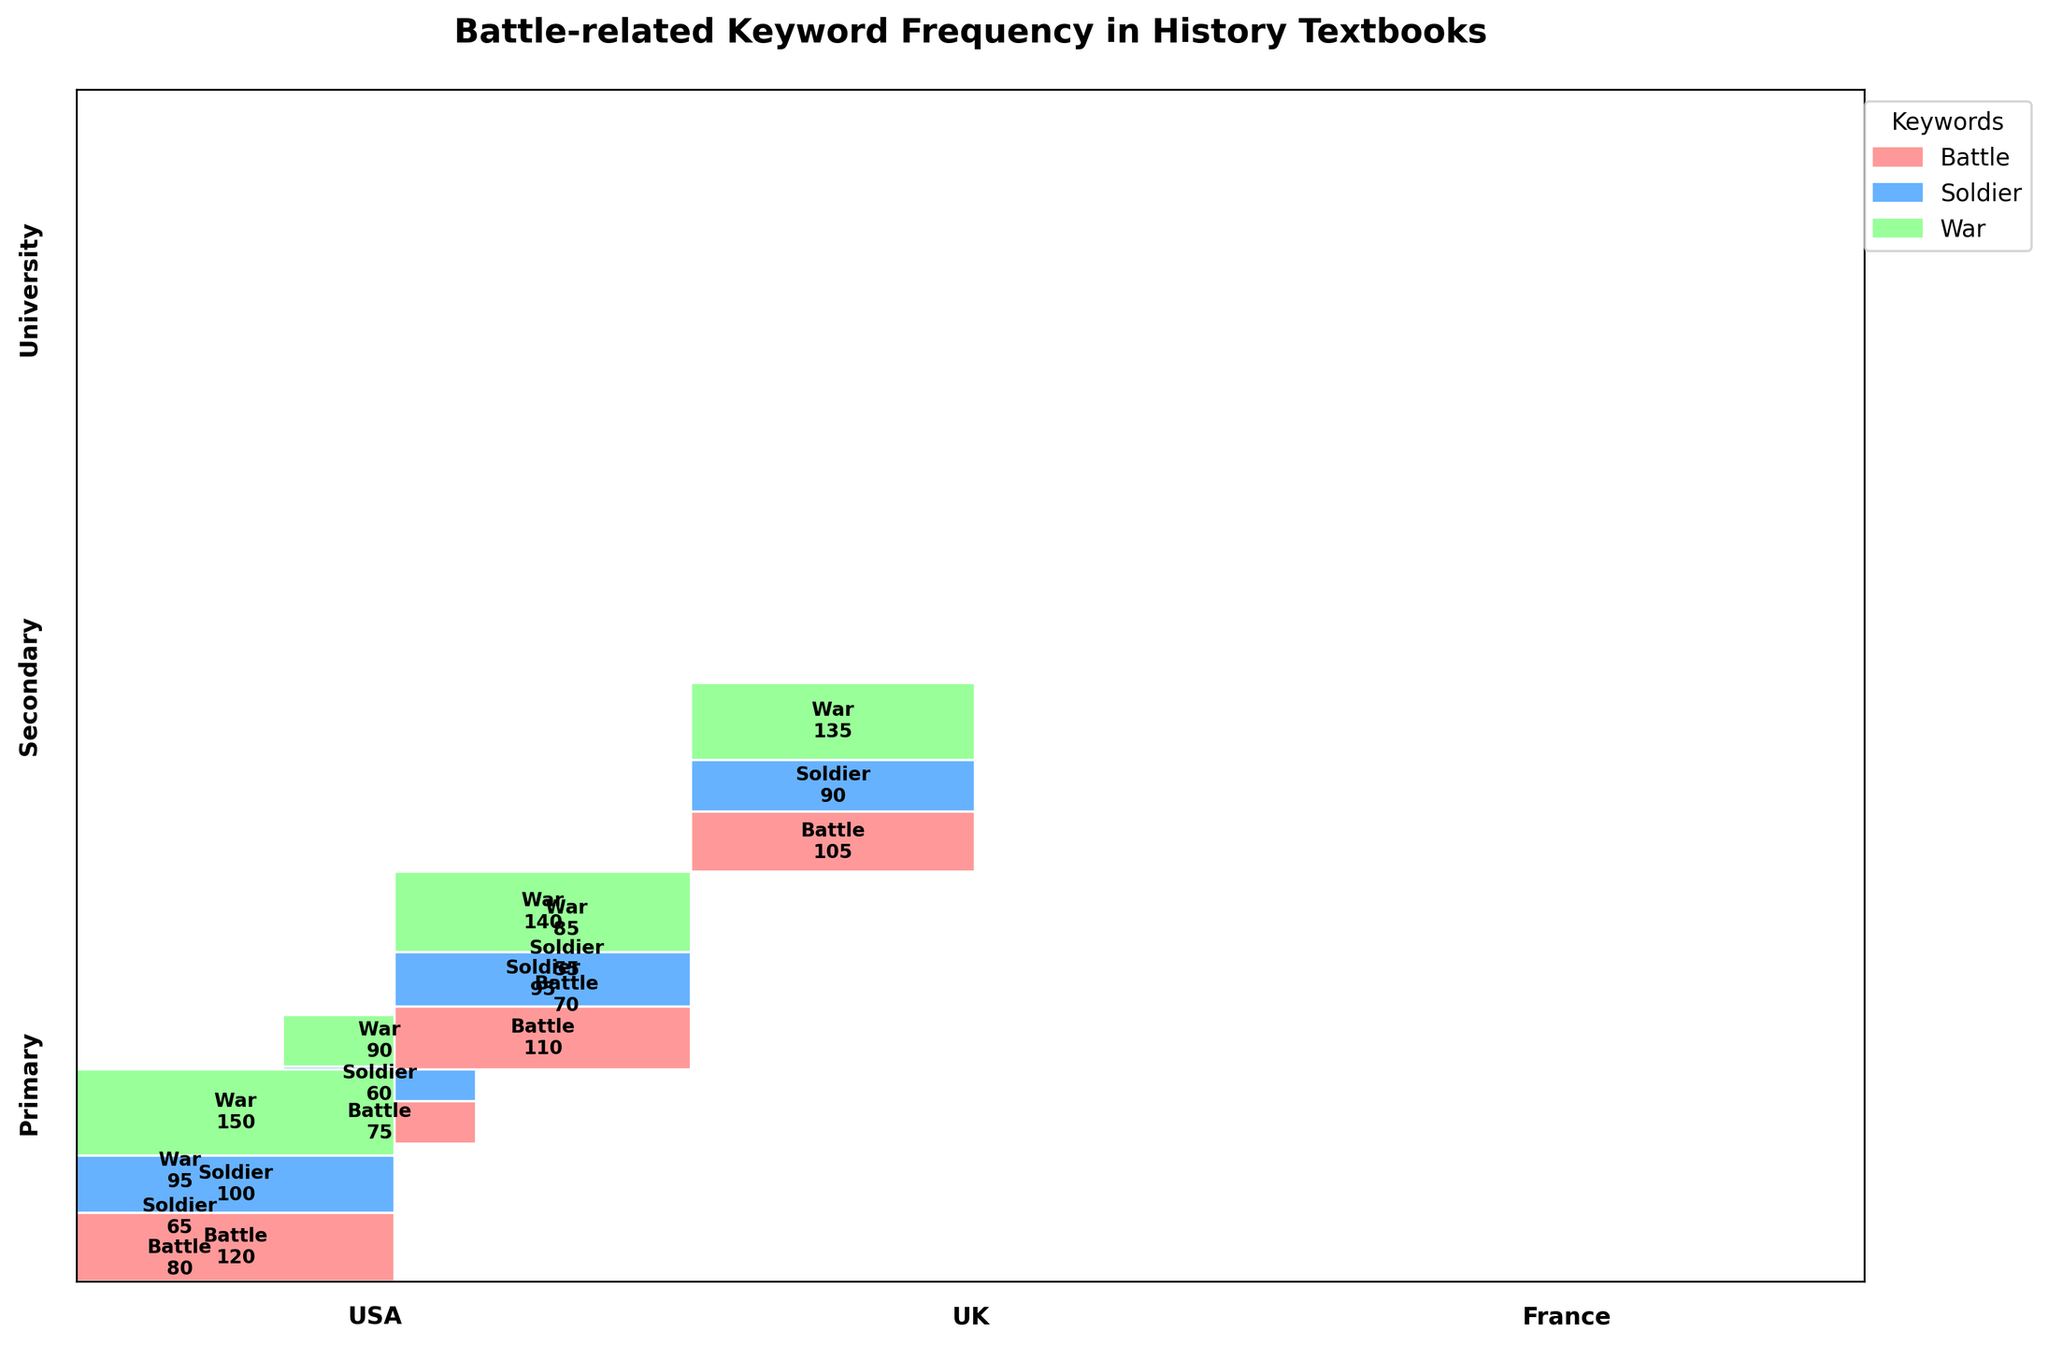What is the title of the plot? The title is usually situated at the top of the plot and provides a brief indication of what the plot is about. In this case, the title explicitly states the focus of the plot.
Answer: Battle-related Keyword Frequency in History Textbooks Which color represents the keyword "Soldier"? The legend on the plot indicates the color coding for each keyword. The color corresponding to "Soldier" is shown in the legend.
Answer: Blue Which educational level has the highest frequency of keywords in the USA? By observing the height of rectangles within each educational level category, the educational level with the highest combined height for the USA can be identified.
Answer: University How many countries are analyzed in this plot? There are different sections on the x-axis, each labeled with a country name. Counting these sections gives the number of countries.
Answer: 3 Which keyword has the highest frequency at the Primary educational level in the UK? In the section for Primary education level in the UK, the height of the rectangles represents the frequency. The tallest rectangle within this section corresponds to the most frequent keyword.
Answer: War Compare the frequency of the keyword "Battle" between the Primary and Secondary levels in France. Which level has a higher frequency? Comparing the heights of the rectangles for the keyword "Battle" in the Primary and Secondary levels for France, the taller rectangle indicates the higher frequency.
Answer: Secondary What is the total frequency of the keyword "War" across all educational levels in the UK? Sum the frequencies of the keyword "War" at all educational levels (Primary, Secondary, and University) in the UK.
Answer: 55 + 90 + 140 = 285 Which keyword has the lowest frequency at the Secondary level in the USA? Within the Secondary level section for the USA, compare the heights of the rectangles representing each keyword. The shortest rectangle represents the keyword with the lowest frequency.
Answer: Soldier What is the difference in the frequency of the keyword "Battle" between the University levels in the USA and France? Subtract the frequency of the keyword "Battle" at the University level in France from that in the USA.
Answer: 120 - 105 = 15 Is the keyword "War" more frequently mentioned at the University level compared to the Secondary level in all countries? Provide evidence from the plot. For each country, compare the heights of the rectangles for the keyword "War" at the University and Secondary levels. If the height is greater in the University level for all countries, then it is more frequent.
Answer: Yes, the rectangles for "War" are taller at the University level in the USA, UK, and France 